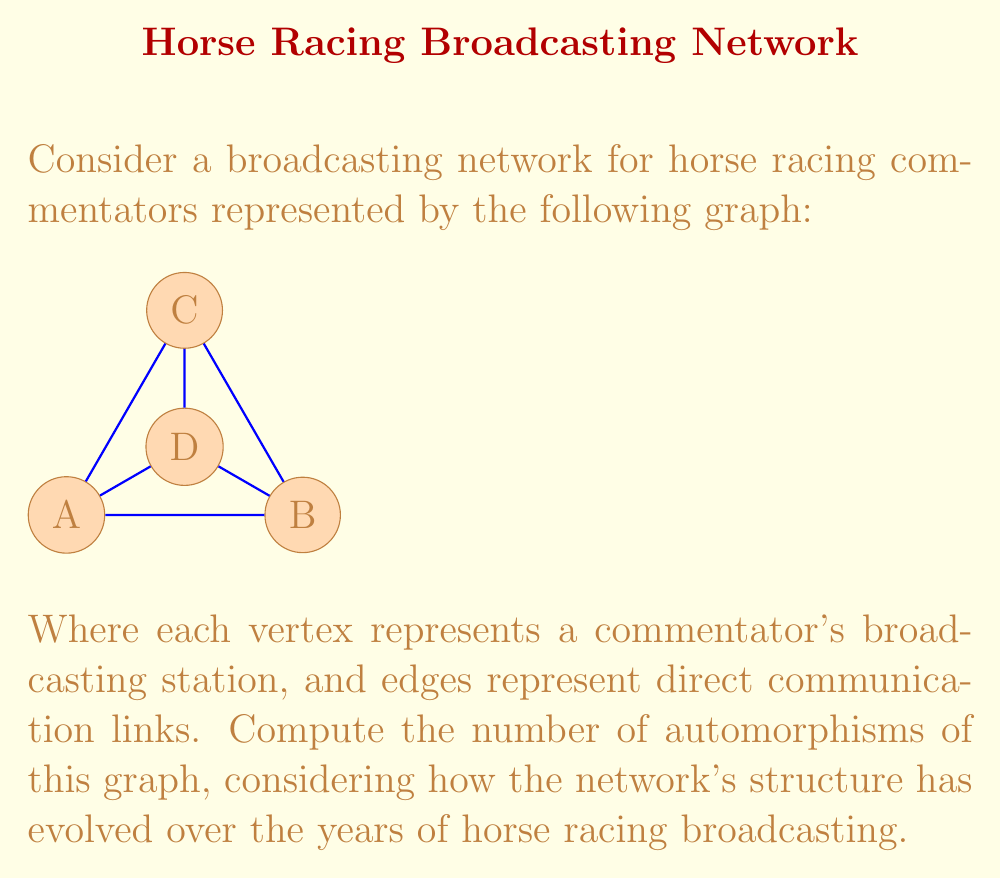Solve this math problem. To solve this problem, we need to follow these steps:

1) First, let's analyze the graph structure:
   - It's a complete graph K4 with one edge removed (the edge between A and C).
   - Vertices A and B have degree 3, while C and D have degree 3 as well.

2) An automorphism of a graph is a permutation of its vertices that preserves adjacency. In other words, it's a way to rearrange the vertices so that the graph structure remains the same.

3) Let's consider the possible automorphisms:
   - A and B can be swapped, as they have the same degree and connections.
   - C and D can be swapped, as they also have the same degree and connections.
   - However, A or B cannot be swapped with C or D, as this would change the graph structure.

4) Therefore, we have two independent choices:
   - We can either keep A and B in place or swap them.
   - We can either keep C and D in place or swap them.

5) The total number of automorphisms is thus:
   $$2 \times 2 = 4$$

These four automorphisms are:
1. Identity (no changes)
2. Swap A and B
3. Swap C and D
4. Swap both (A,B) and (C,D)

This reflects how the broadcasting network has maintained its core structure over the years, with certain stations (represented by vertices) being interchangeable in terms of their connections, while the overall network topology has remained consistent.
Answer: The graph has 4 automorphisms. 